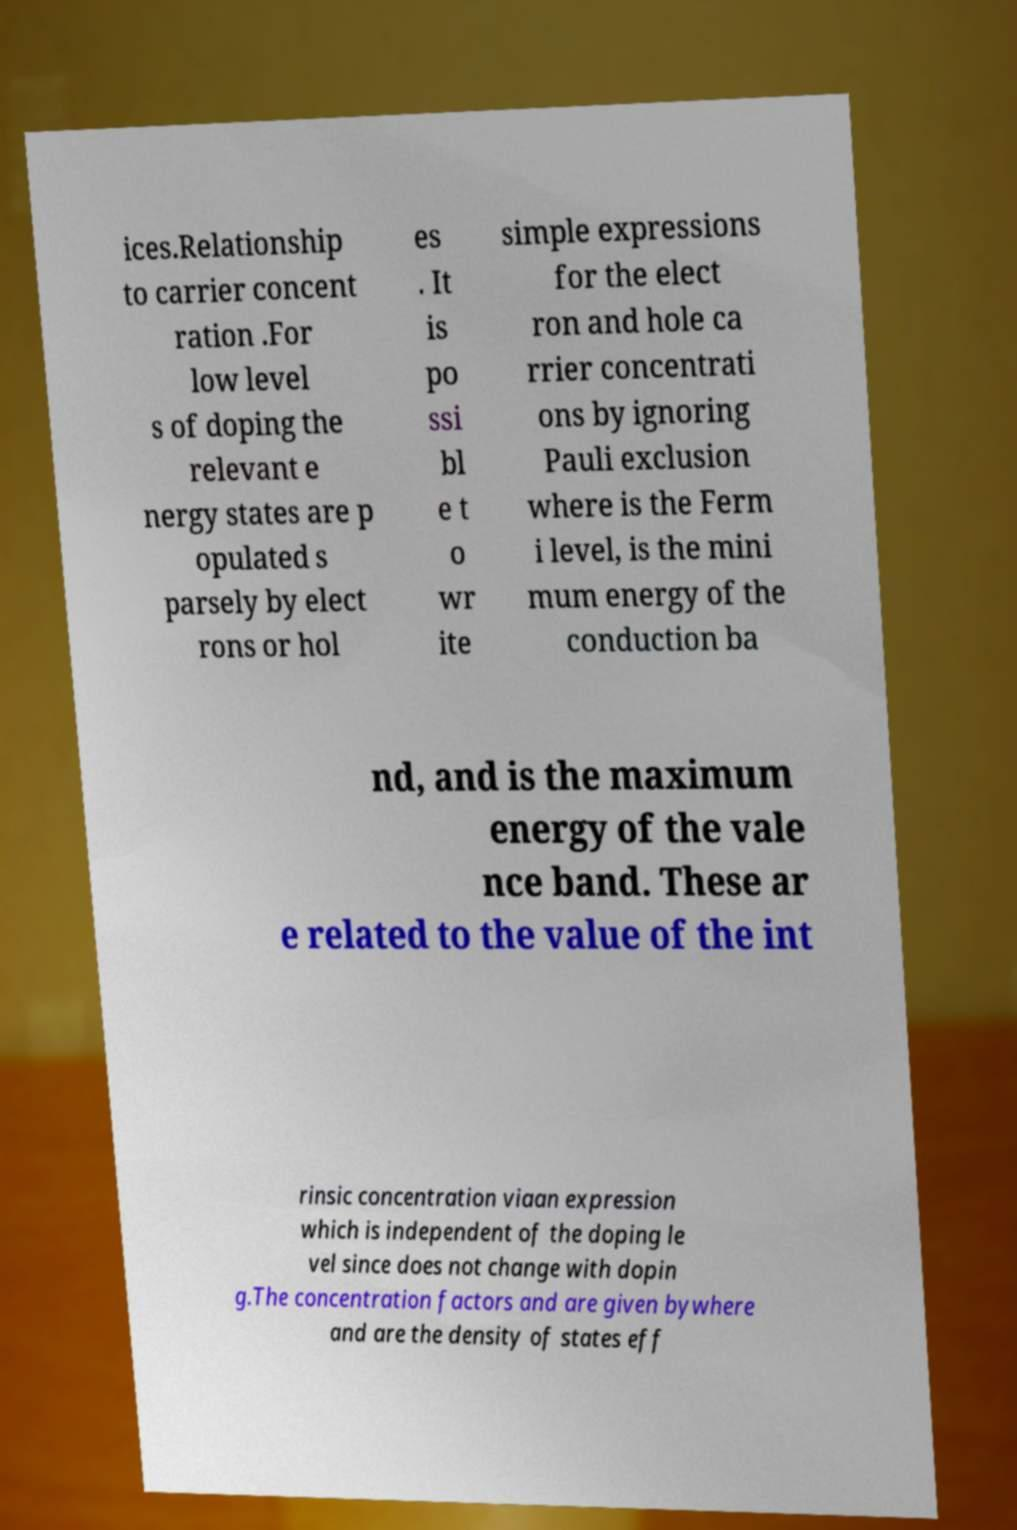Could you assist in decoding the text presented in this image and type it out clearly? ices.Relationship to carrier concent ration .For low level s of doping the relevant e nergy states are p opulated s parsely by elect rons or hol es . It is po ssi bl e t o wr ite simple expressions for the elect ron and hole ca rrier concentrati ons by ignoring Pauli exclusion where is the Ferm i level, is the mini mum energy of the conduction ba nd, and is the maximum energy of the vale nce band. These ar e related to the value of the int rinsic concentration viaan expression which is independent of the doping le vel since does not change with dopin g.The concentration factors and are given bywhere and are the density of states eff 